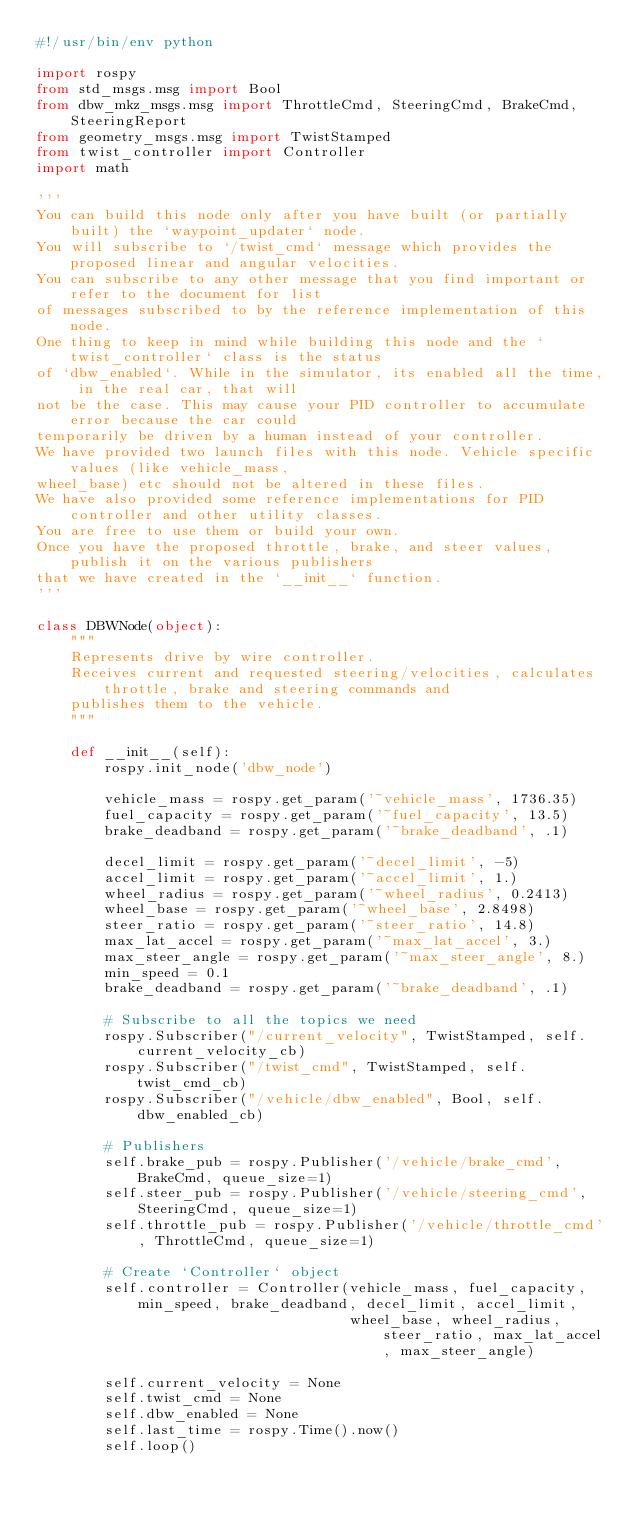Convert code to text. <code><loc_0><loc_0><loc_500><loc_500><_Python_>#!/usr/bin/env python

import rospy
from std_msgs.msg import Bool
from dbw_mkz_msgs.msg import ThrottleCmd, SteeringCmd, BrakeCmd, SteeringReport
from geometry_msgs.msg import TwistStamped
from twist_controller import Controller
import math

'''
You can build this node only after you have built (or partially built) the `waypoint_updater` node.
You will subscribe to `/twist_cmd` message which provides the proposed linear and angular velocities.
You can subscribe to any other message that you find important or refer to the document for list
of messages subscribed to by the reference implementation of this node.
One thing to keep in mind while building this node and the `twist_controller` class is the status
of `dbw_enabled`. While in the simulator, its enabled all the time, in the real car, that will
not be the case. This may cause your PID controller to accumulate error because the car could
temporarily be driven by a human instead of your controller.
We have provided two launch files with this node. Vehicle specific values (like vehicle_mass,
wheel_base) etc should not be altered in these files.
We have also provided some reference implementations for PID controller and other utility classes.
You are free to use them or build your own.
Once you have the proposed throttle, brake, and steer values, publish it on the various publishers
that we have created in the `__init__` function.
'''

class DBWNode(object):
    """
    Represents drive by wire controller.
    Receives current and requested steering/velocities, calculates throttle, brake and steering commands and
    publishes them to the vehicle.
    """

    def __init__(self):
        rospy.init_node('dbw_node')

        vehicle_mass = rospy.get_param('~vehicle_mass', 1736.35)
        fuel_capacity = rospy.get_param('~fuel_capacity', 13.5)
        brake_deadband = rospy.get_param('~brake_deadband', .1)

        decel_limit = rospy.get_param('~decel_limit', -5)
        accel_limit = rospy.get_param('~accel_limit', 1.)
        wheel_radius = rospy.get_param('~wheel_radius', 0.2413)
        wheel_base = rospy.get_param('~wheel_base', 2.8498)
        steer_ratio = rospy.get_param('~steer_ratio', 14.8)
        max_lat_accel = rospy.get_param('~max_lat_accel', 3.)
        max_steer_angle = rospy.get_param('~max_steer_angle', 8.)
        min_speed = 0.1
        brake_deadband = rospy.get_param('~brake_deadband', .1)

        # Subscribe to all the topics we need
        rospy.Subscriber("/current_velocity", TwistStamped, self.current_velocity_cb)
        rospy.Subscriber("/twist_cmd", TwistStamped, self.twist_cmd_cb)
        rospy.Subscriber("/vehicle/dbw_enabled", Bool, self.dbw_enabled_cb)

        # Publishers
        self.brake_pub = rospy.Publisher('/vehicle/brake_cmd', BrakeCmd, queue_size=1)
        self.steer_pub = rospy.Publisher('/vehicle/steering_cmd', SteeringCmd, queue_size=1)
        self.throttle_pub = rospy.Publisher('/vehicle/throttle_cmd', ThrottleCmd, queue_size=1)

        # Create `Controller` object
        self.controller = Controller(vehicle_mass, fuel_capacity, min_speed, brake_deadband, decel_limit, accel_limit,
                                     wheel_base, wheel_radius, steer_ratio, max_lat_accel, max_steer_angle)

        self.current_velocity = None
        self.twist_cmd = None
        self.dbw_enabled = None
        self.last_time = rospy.Time().now()
        self.loop()

</code> 